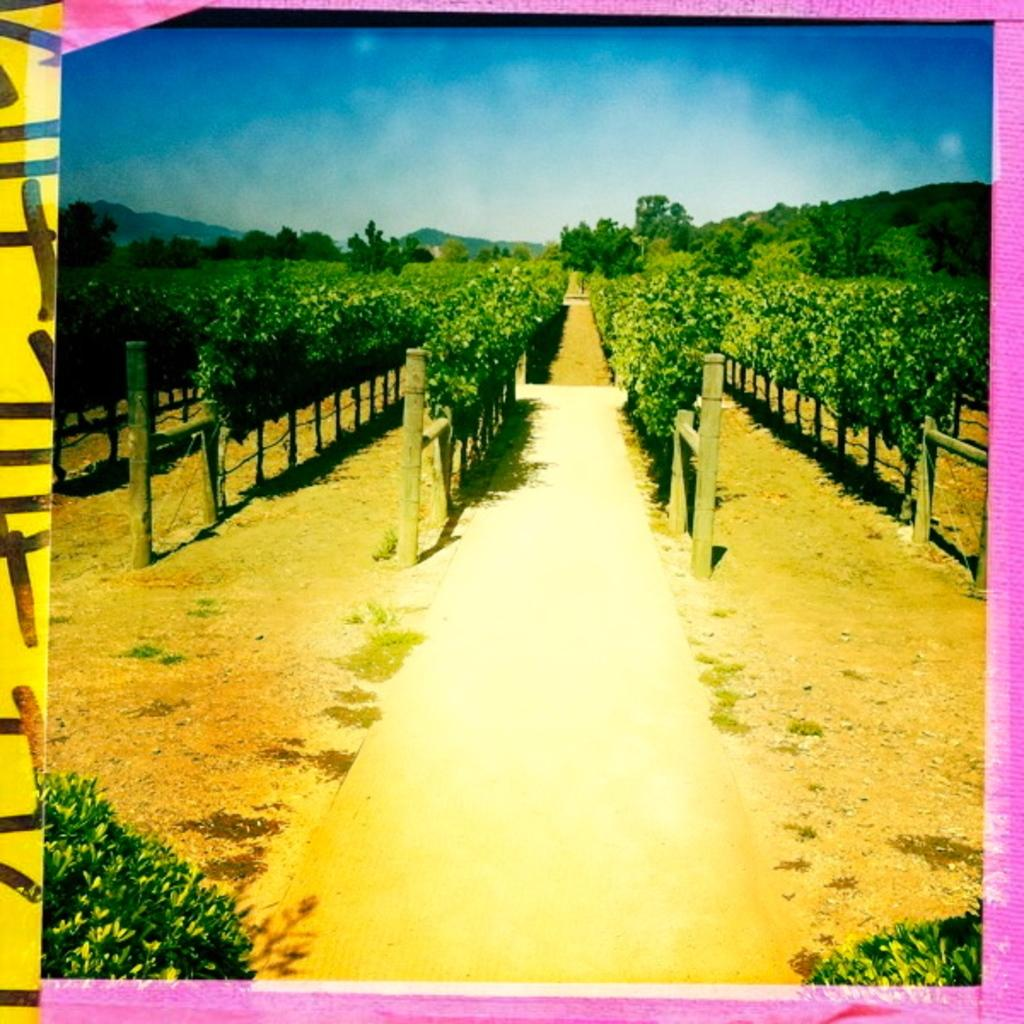What type of vegetation is present in the image? There are trees in the image. Are there any other plants visible in the image? Yes, there are two plants at the bottom of the image. What can be seen in the background of the image? The sky is visible at the top of the image. What type of horn can be heard in the image? There is no horn present in the image, so it cannot be heard. 